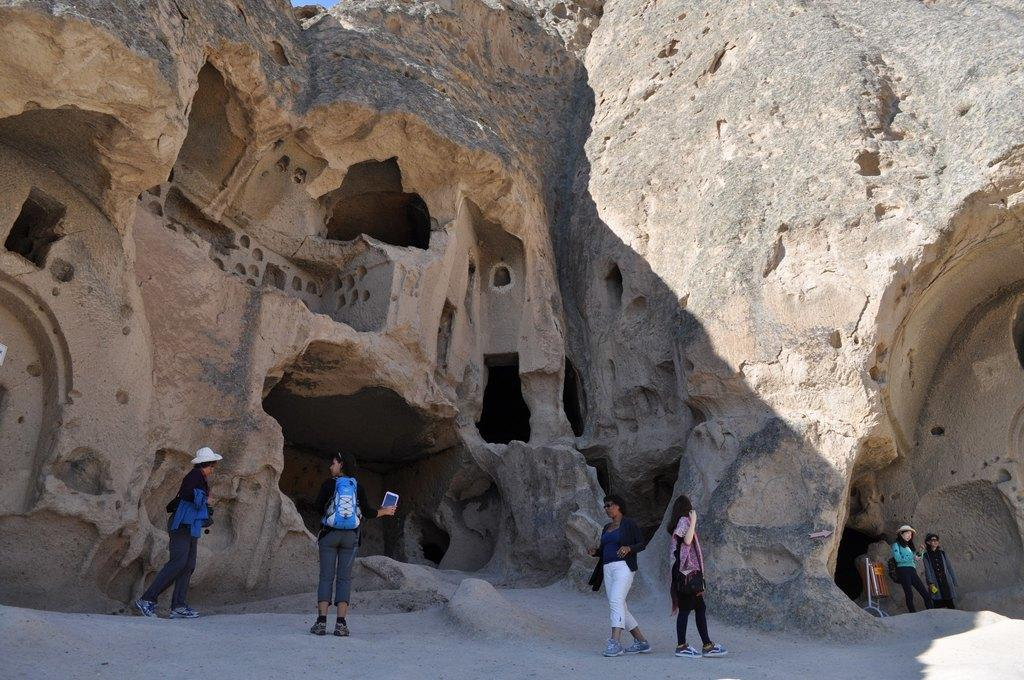What type of structure is depicted in the image? The image appears to depict an old monument. What features can be seen on the monument? The monument has rocks and caves. Are there any people present in the image? Yes, there are people standing in the image. What invention is being used by the laborer in the image? There is no laborer or invention present in the image. How does the throat of the person in the image feel? There is no information about the person's throat in the image. 